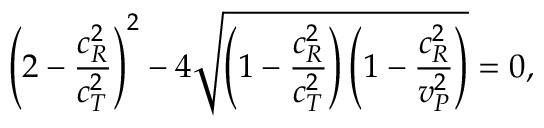Convert formula to latex. <formula><loc_0><loc_0><loc_500><loc_500>\left ( 2 - \frac { c _ { R } ^ { 2 } } { c _ { T } ^ { 2 } } \right ) ^ { 2 } - 4 \sqrt { \left ( 1 - \frac { c _ { R } ^ { 2 } } { c _ { T } ^ { 2 } } \right ) \left ( 1 - \frac { c _ { R } ^ { 2 } } { v _ { P } ^ { 2 } } \right ) } = 0 ,</formula> 